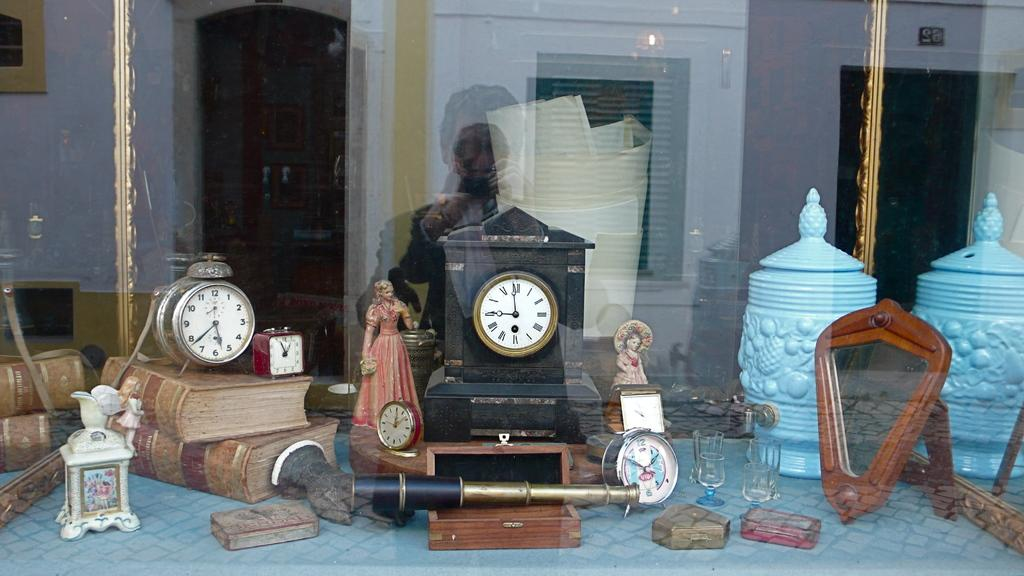<image>
Summarize the visual content of the image. A display of antique clocks sits on a table with the red clock pointing to the numbers 11 and 1 